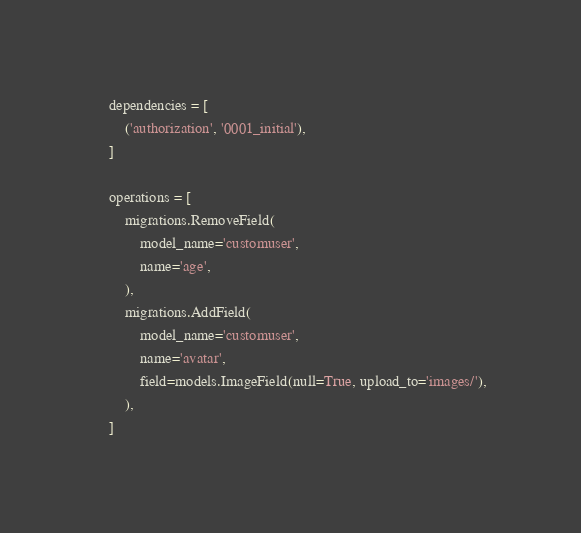<code> <loc_0><loc_0><loc_500><loc_500><_Python_>    dependencies = [
        ('authorization', '0001_initial'),
    ]

    operations = [
        migrations.RemoveField(
            model_name='customuser',
            name='age',
        ),
        migrations.AddField(
            model_name='customuser',
            name='avatar',
            field=models.ImageField(null=True, upload_to='images/'),
        ),
    ]
</code> 